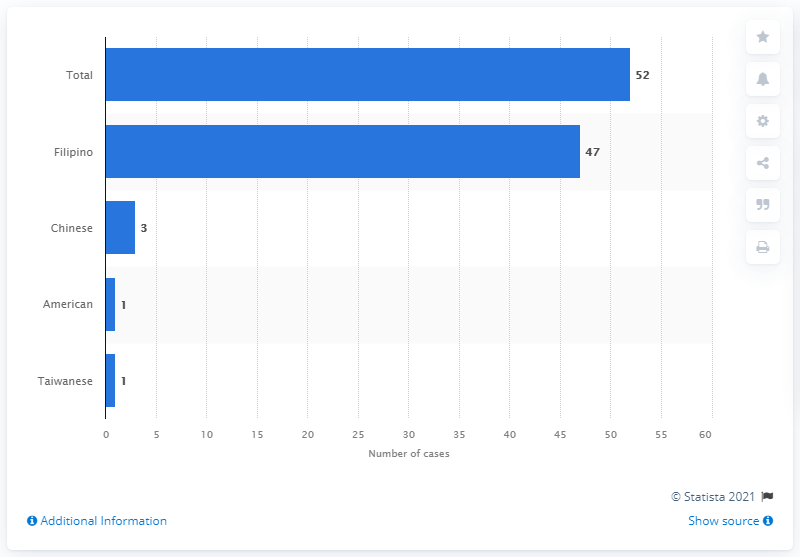Mention a couple of crucial points in this snapshot. As of March 12, 2020, there were 52 confirmed cases of COVID-19 in the Philippines. Out of the total number of confirmed cases of COVID-19, 47 were identified as Filipinos. 